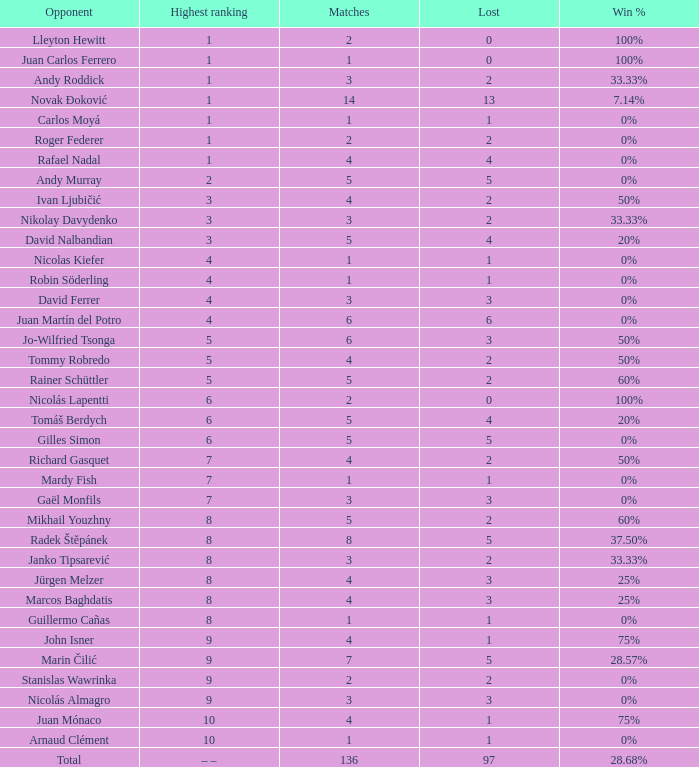Can you parse all the data within this table? {'header': ['Opponent', 'Highest ranking', 'Matches', 'Lost', 'Win %'], 'rows': [['Lleyton Hewitt', '1', '2', '0', '100%'], ['Juan Carlos Ferrero', '1', '1', '0', '100%'], ['Andy Roddick', '1', '3', '2', '33.33%'], ['Novak Đoković', '1', '14', '13', '7.14%'], ['Carlos Moyá', '1', '1', '1', '0%'], ['Roger Federer', '1', '2', '2', '0%'], ['Rafael Nadal', '1', '4', '4', '0%'], ['Andy Murray', '2', '5', '5', '0%'], ['Ivan Ljubičić', '3', '4', '2', '50%'], ['Nikolay Davydenko', '3', '3', '2', '33.33%'], ['David Nalbandian', '3', '5', '4', '20%'], ['Nicolas Kiefer', '4', '1', '1', '0%'], ['Robin Söderling', '4', '1', '1', '0%'], ['David Ferrer', '4', '3', '3', '0%'], ['Juan Martín del Potro', '4', '6', '6', '0%'], ['Jo-Wilfried Tsonga', '5', '6', '3', '50%'], ['Tommy Robredo', '5', '4', '2', '50%'], ['Rainer Schüttler', '5', '5', '2', '60%'], ['Nicolás Lapentti', '6', '2', '0', '100%'], ['Tomáš Berdych', '6', '5', '4', '20%'], ['Gilles Simon', '6', '5', '5', '0%'], ['Richard Gasquet', '7', '4', '2', '50%'], ['Mardy Fish', '7', '1', '1', '0%'], ['Gaël Monfils', '7', '3', '3', '0%'], ['Mikhail Youzhny', '8', '5', '2', '60%'], ['Radek Štěpánek', '8', '8', '5', '37.50%'], ['Janko Tipsarević', '8', '3', '2', '33.33%'], ['Jürgen Melzer', '8', '4', '3', '25%'], ['Marcos Baghdatis', '8', '4', '3', '25%'], ['Guillermo Cañas', '8', '1', '1', '0%'], ['John Isner', '9', '4', '1', '75%'], ['Marin Čilić', '9', '7', '5', '28.57%'], ['Stanislas Wawrinka', '9', '2', '2', '0%'], ['Nicolás Almagro', '9', '3', '3', '0%'], ['Juan Mónaco', '10', '4', '1', '75%'], ['Arnaud Clément', '10', '1', '1', '0%'], ['Total', '– –', '136', '97', '28.68%']]} What is the largest number Lost to david nalbandian with a Win Rate of 20%? 4.0. 